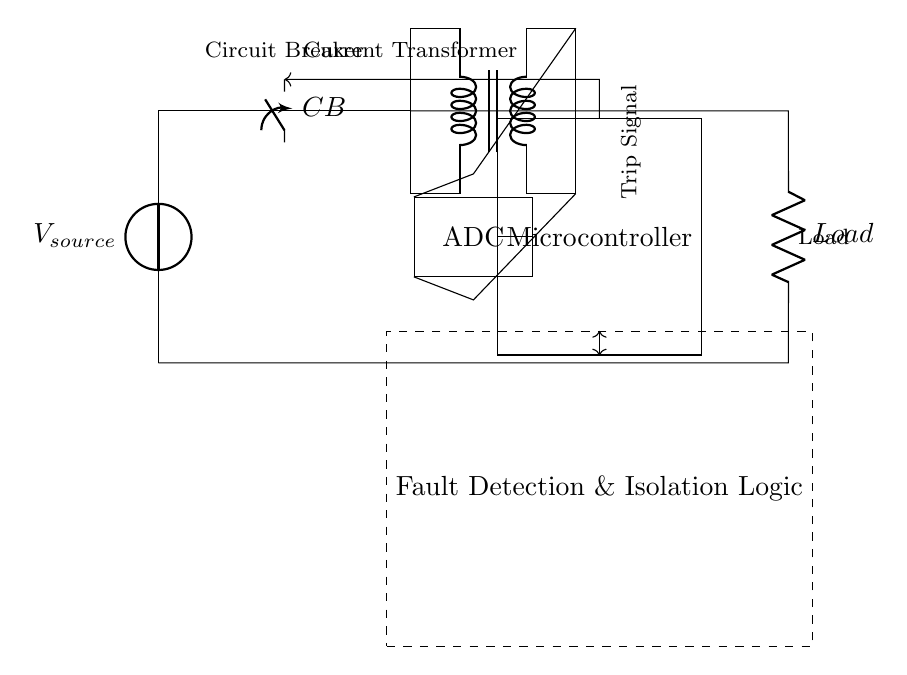What is the primary purpose of the circuit? The primary purpose is to provide overcurrent protection by detecting faults and isolating the load using a microcontroller-based system.
Answer: Overcurrent protection What component is used to detect current in the circuit? The component specifically used for current detection is the current transformer, which converts the primary current into a manageable secondary current for measurement.
Answer: Current transformer Which component initiates the trip signal? The microcontroller is responsible for initiating the trip signal when it detects an overcurrent condition through the fault detection logic.
Answer: Microcontroller How many main functional components are indicated in the circuit? The circuit diagram shows four main functional components: the power source, circuit breaker, current transformer, and microcontroller.
Answer: Four What kind of logic is used for fault detection and isolation? The fault detection and isolation logic is represented as a separate box in the circuit and is responsible for determining when a trip signal should be sent.
Answer: Fault detection and isolation logic What kind of output does the ADC provide in this circuit? The ADC provides a digital representation of the analog current signal received from the current transformer, allowing the microcontroller to process this information.
Answer: Digital current signal How does the circuit ensure safety during faults? It ensures safety by using a circuit breaker that opens the circuit when a trip signal is received, disconnecting the load and preventing damage from overcurrent conditions.
Answer: Circuit breaker 